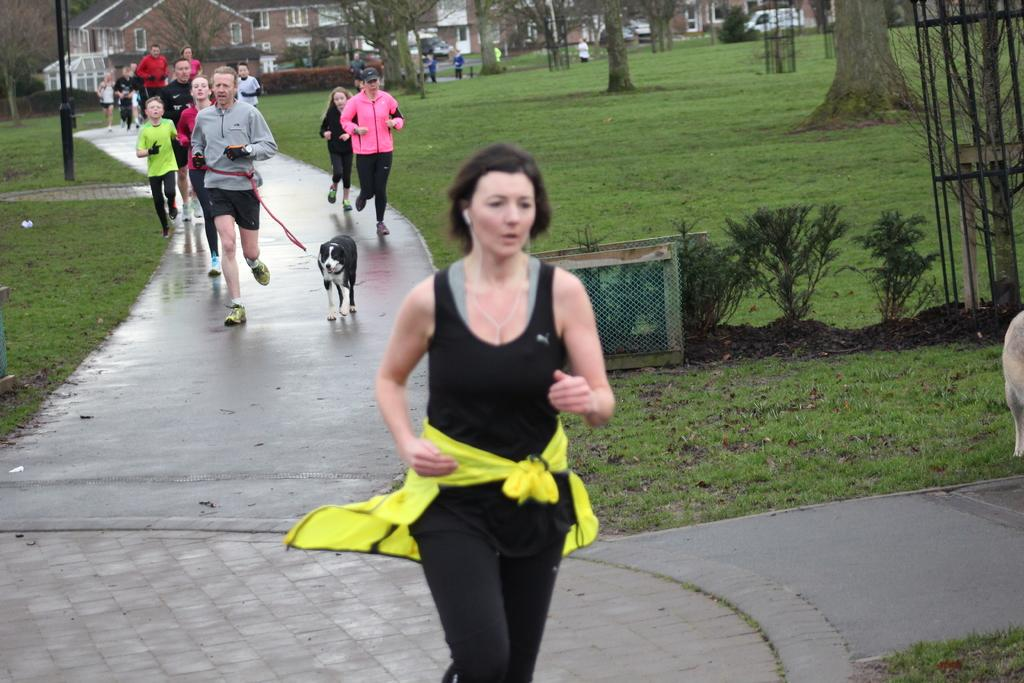What are the people in the image doing? The people in the image are running. Can you describe the man running in the image? The man is running with a dog on a string. What type of surface is the people running on? The ground has grass. What can be seen in the background of the image? There are trees and buildings in the image. What type of pet is the man wearing on his head in the image? There is no pet visible on the man's head in the image. Can you describe the mitten the dog is holding in the image? There is no mitten present in the image; the dog is on a string. 